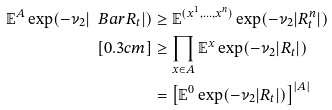Convert formula to latex. <formula><loc_0><loc_0><loc_500><loc_500>\mathbb { E } ^ { A } \exp ( - \nu _ { 2 } | \ B a r R _ { t } | ) & \geq \mathbb { E } ^ { ( x ^ { 1 } , \dots , x ^ { n } ) } \exp ( - \nu _ { 2 } | R _ { t } ^ { n } | ) \\ [ 0 . 3 c m ] & \geq \prod _ { x \in A } \mathbb { E } ^ { x } \exp ( - \nu _ { 2 } | R _ { t } | ) \\ & = \left [ \mathbb { E } ^ { 0 } \exp ( - \nu _ { 2 } | R _ { t } | ) \right ] ^ { | A | }</formula> 